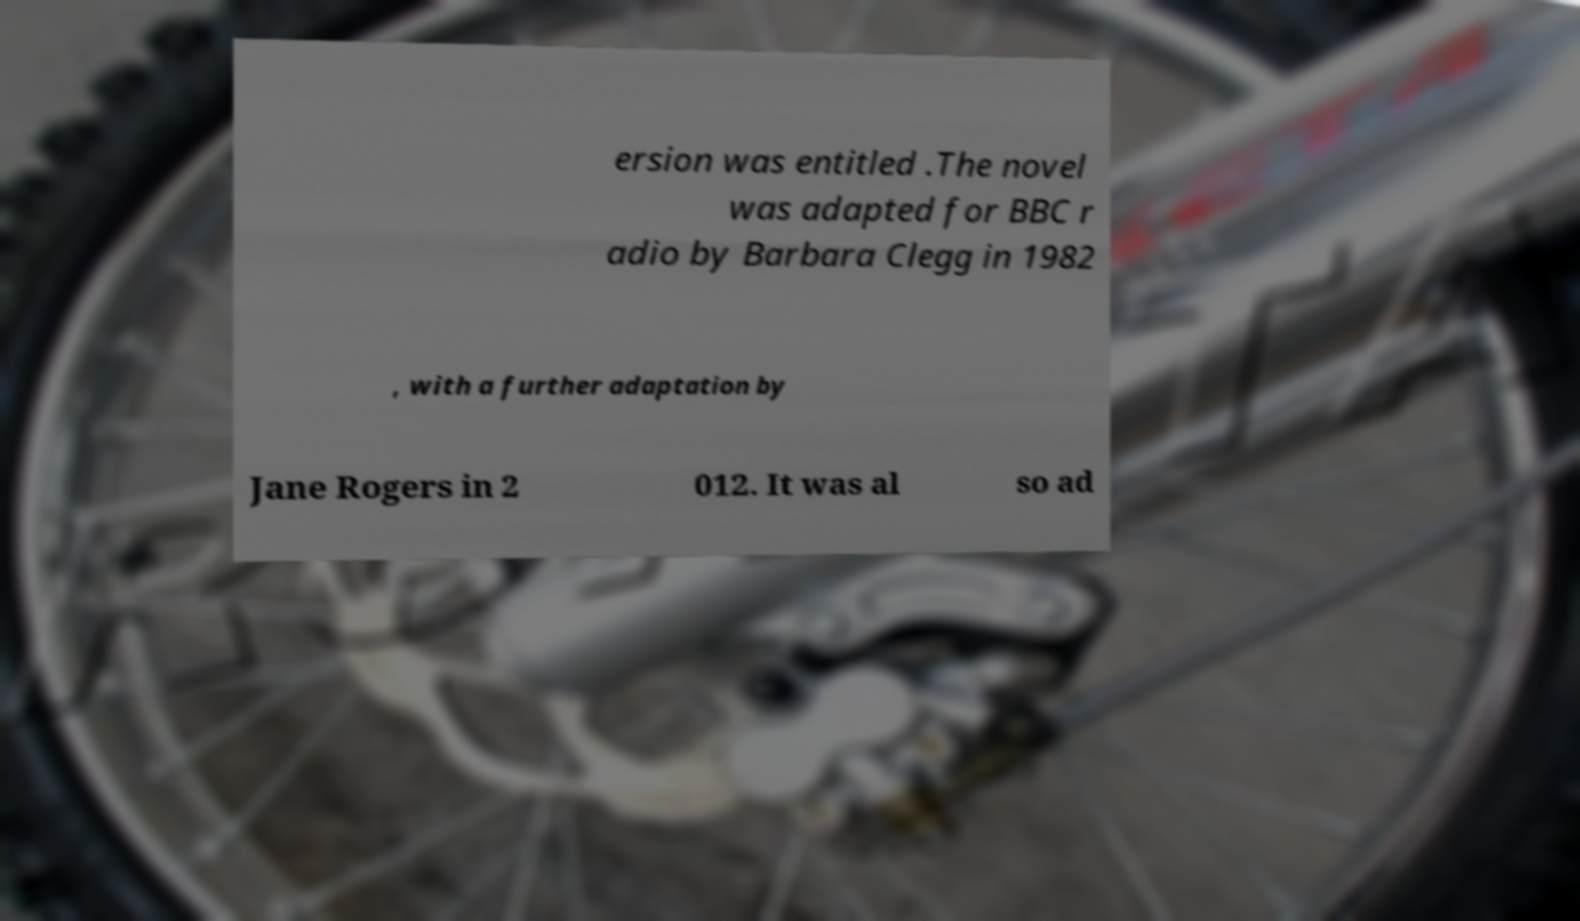Can you read and provide the text displayed in the image?This photo seems to have some interesting text. Can you extract and type it out for me? ersion was entitled .The novel was adapted for BBC r adio by Barbara Clegg in 1982 , with a further adaptation by Jane Rogers in 2 012. It was al so ad 